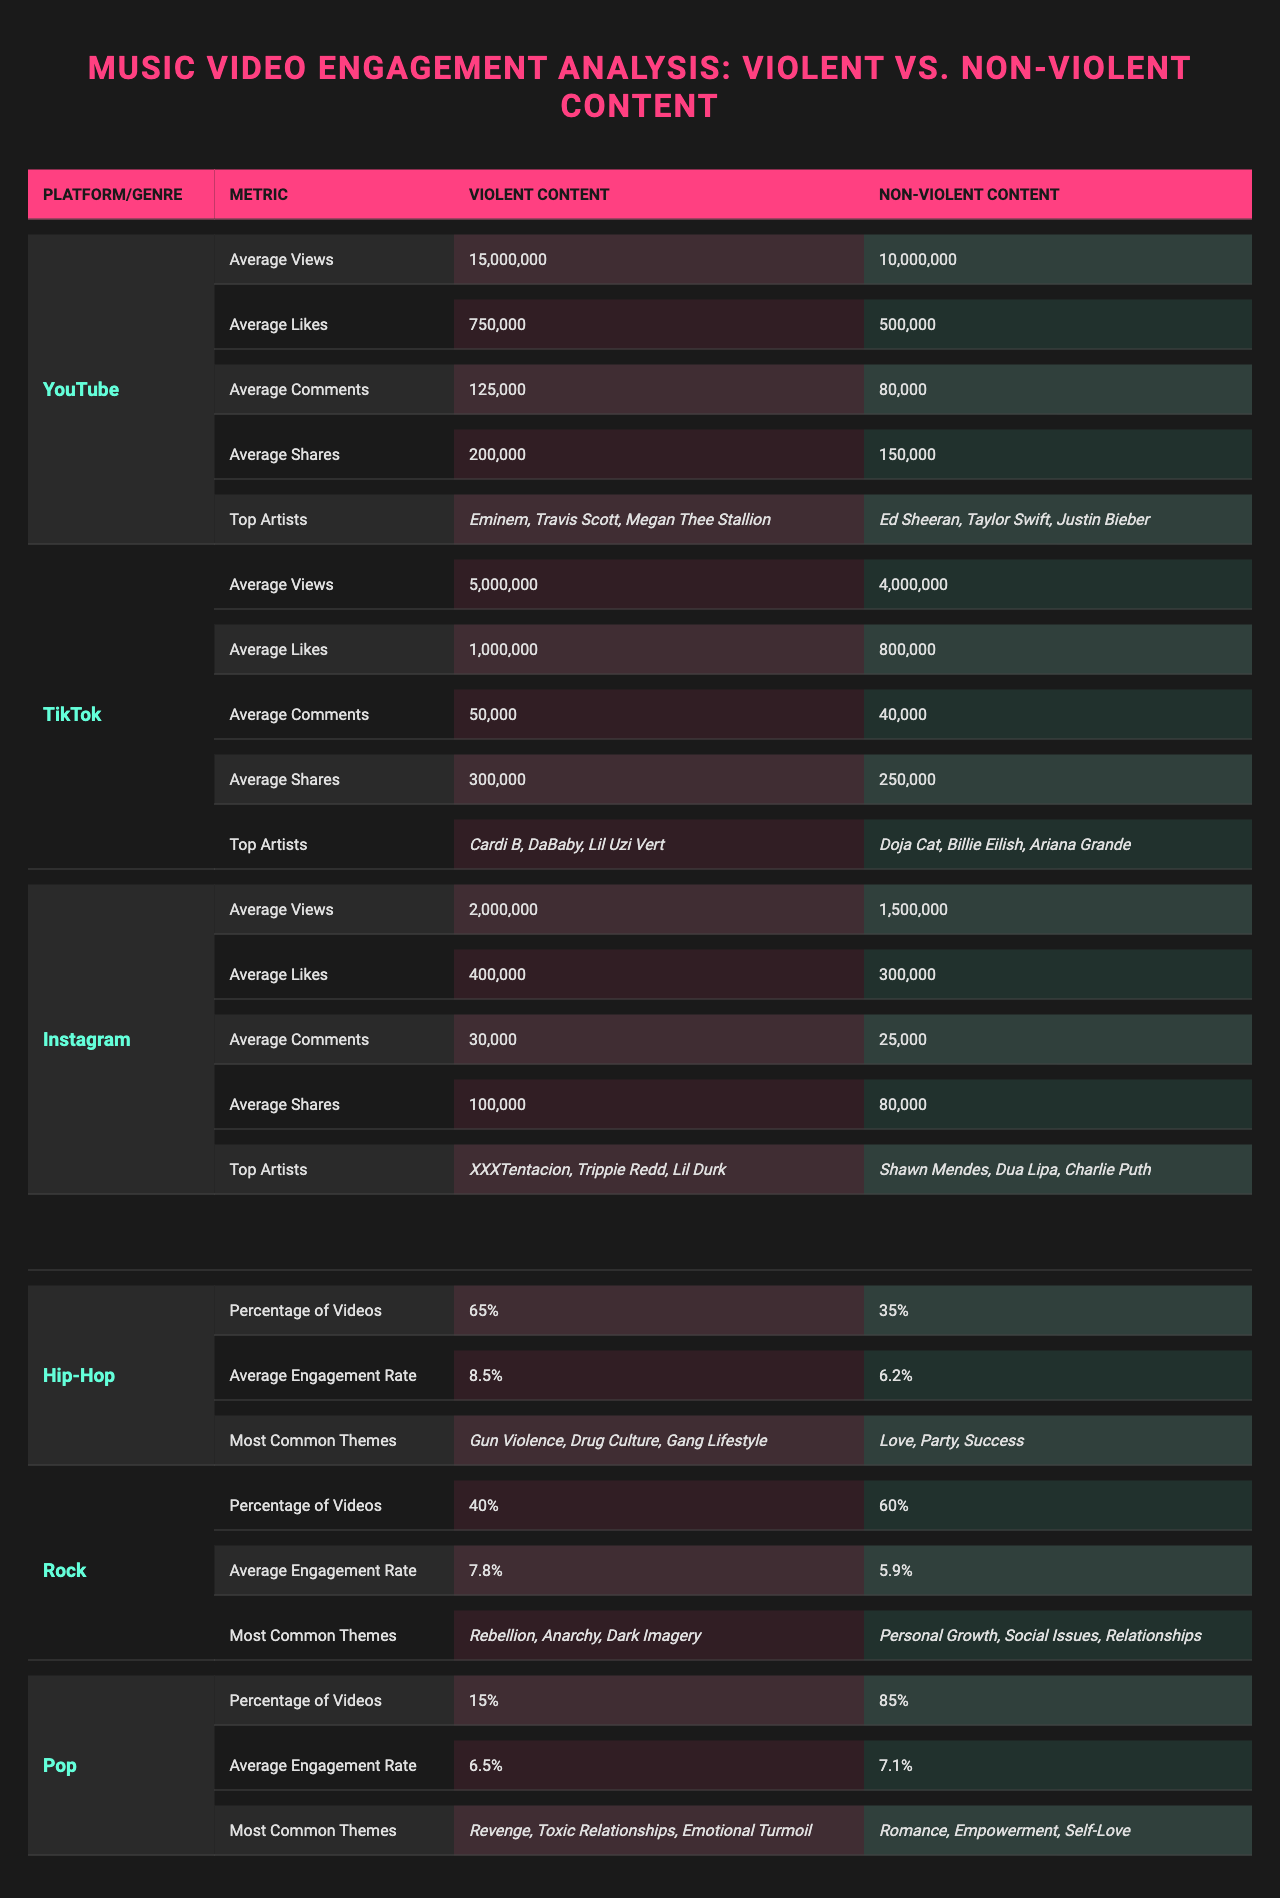What are the average views for music videos with violent content on YouTube? According to the table, the average views for violent content on YouTube is 15,000,000.
Answer: 15,000,000 Which platform has the highest average likes for non-violent content? The table shows that YouTube has the highest average likes for non-violent content, with 500,000 likes.
Answer: YouTube On TikTok, how many more average shares do violent content videos have compared to non-violent ones? The average shares for violent content on TikTok is 300,000, and for non-violent content, it is 250,000. The difference is 300,000 - 250,000 = 50,000.
Answer: 50,000 What percentage of Hip-Hop videos are categorized as violent? The table indicates that 65% of Hip-Hop videos are categorized as violent.
Answer: 65% Is the average engagement rate for non-violent content in the Pop genre higher than that of the Rock genre? Non-violent content in Pop has an average engagement rate of 7.1%, while Rock has 5.9%. Therefore, Pop's rate is higher.
Answer: Yes Which violent content theme is most common in the Hip-Hop genre according to the table? The most common themes for violent content in Hip-Hop include "Gun Violence," "Drug Culture," and "Gang Lifestyle."
Answer: Gun Violence, Drug Culture, Gang Lifestyle What is the average engagement rate for violent content in Rock compared to non-violent content? The average engagement rate for violent content in Rock is 7.8%, while for non-violent content it is 5.9%. The difference is 7.8% - 5.9% = 1.9%.
Answer: 1.9% Identify the top artist associated with violent content on Instagram. According to the table, one of the top artists associated with violent content on Instagram is XXXTentacion.
Answer: XXXTentacion Which genre has the lowest percentage of videos classified as violent content? The Pop genre has the lowest percentage of violent videos at 15%.
Answer: 15% If we compare average comments for violent content across platforms, which platform has the lowest? The average comments for violent content on Instagram are 30,000, which is lower than YouTube and TikTok (125,000 and 50,000 respectively).
Answer: Instagram What can be inferred about the engagement rates of violent vs. non-violent content across the genres listed? In general, the average engagement rates for violent content are usually higher compared to non-violent content across all genres represented in the table.
Answer: Violent content generally has higher engagement rates 